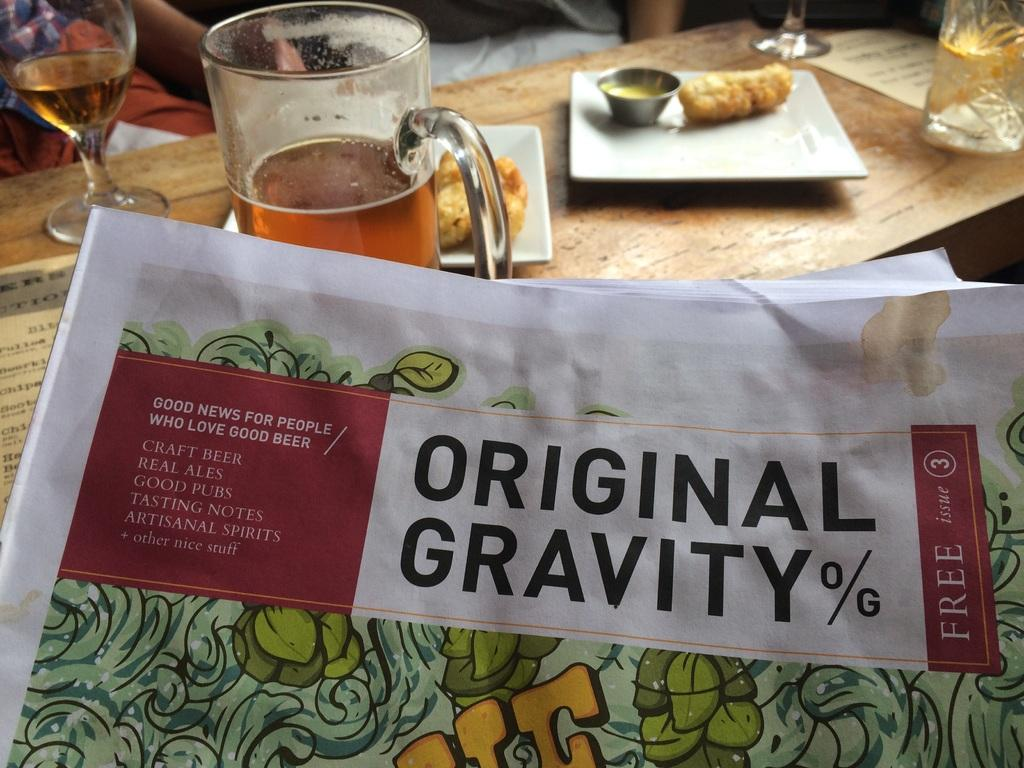What objects are present on the table in the image? There are glasses and plates on the table in the image. What is the purpose of the plates on the table? The plates contain food. What else can be seen in the image besides the table and its contents? There are papers visible in the image. Where is the loaf of bread located in the image? There is no loaf of bread present in the image. What type of fowl can be seen flying in the background of the image? There is no fowl visible in the image; it only features papers, a table, glasses, plates, and food. 